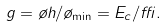Convert formula to latex. <formula><loc_0><loc_0><loc_500><loc_500>g = \tau h / \tau _ { \min } = E _ { c } / \delta .</formula> 